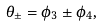<formula> <loc_0><loc_0><loc_500><loc_500>\theta _ { \pm } = \phi _ { 3 } \pm \phi _ { 4 } ,</formula> 